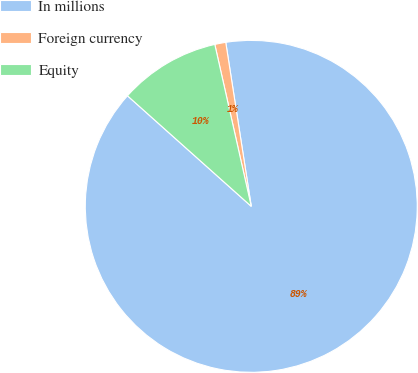Convert chart to OTSL. <chart><loc_0><loc_0><loc_500><loc_500><pie_chart><fcel>In millions<fcel>Foreign currency<fcel>Equity<nl><fcel>89.06%<fcel>1.07%<fcel>9.87%<nl></chart> 